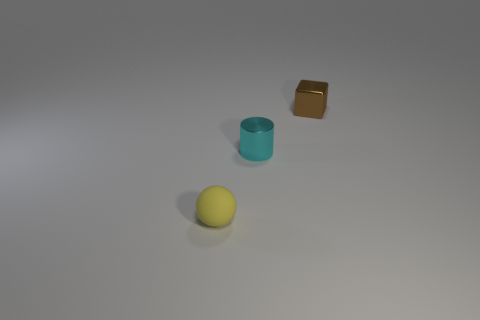There is a sphere that is the same size as the brown metal block; what is it made of?
Your answer should be compact. Rubber. Is there a small cube that has the same material as the cylinder?
Ensure brevity in your answer.  Yes. What number of objects are things that are right of the small sphere or yellow things?
Offer a very short reply. 3. Do the thing that is right of the cyan metallic thing and the tiny cyan cylinder have the same material?
Offer a very short reply. Yes. Is the tiny yellow thing the same shape as the brown object?
Offer a terse response. No. There is a metal object in front of the cube; how many rubber spheres are to the left of it?
Offer a terse response. 1. Does the cylinder have the same material as the thing that is behind the small cyan metal cylinder?
Give a very brief answer. Yes. What is the shape of the tiny metal object to the left of the cube?
Make the answer very short. Cylinder. What number of other things are made of the same material as the yellow thing?
Your answer should be very brief. 0. What color is the object that is both to the right of the yellow matte object and left of the small brown metal block?
Give a very brief answer. Cyan. 